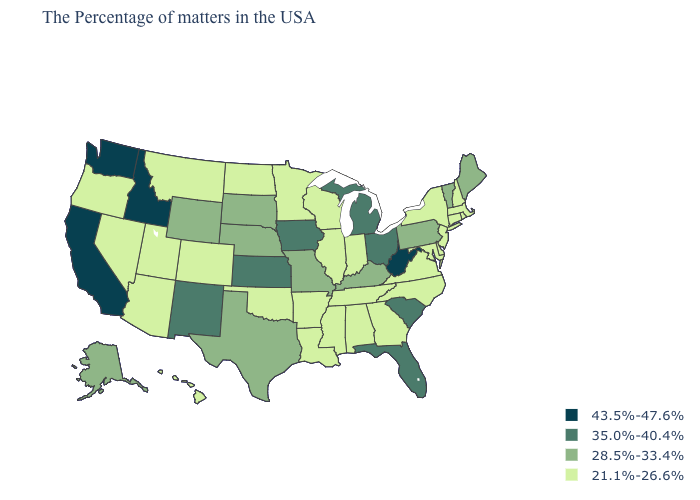What is the highest value in states that border Idaho?
Give a very brief answer. 43.5%-47.6%. Which states have the lowest value in the West?
Write a very short answer. Colorado, Utah, Montana, Arizona, Nevada, Oregon, Hawaii. Name the states that have a value in the range 21.1%-26.6%?
Be succinct. Massachusetts, Rhode Island, New Hampshire, Connecticut, New York, New Jersey, Delaware, Maryland, Virginia, North Carolina, Georgia, Indiana, Alabama, Tennessee, Wisconsin, Illinois, Mississippi, Louisiana, Arkansas, Minnesota, Oklahoma, North Dakota, Colorado, Utah, Montana, Arizona, Nevada, Oregon, Hawaii. Does South Dakota have the same value as Mississippi?
Be succinct. No. What is the value of New Hampshire?
Quick response, please. 21.1%-26.6%. Which states have the highest value in the USA?
Short answer required. West Virginia, Idaho, California, Washington. Name the states that have a value in the range 28.5%-33.4%?
Short answer required. Maine, Vermont, Pennsylvania, Kentucky, Missouri, Nebraska, Texas, South Dakota, Wyoming, Alaska. What is the value of Idaho?
Answer briefly. 43.5%-47.6%. Name the states that have a value in the range 43.5%-47.6%?
Write a very short answer. West Virginia, Idaho, California, Washington. What is the value of South Dakota?
Give a very brief answer. 28.5%-33.4%. What is the value of Kansas?
Concise answer only. 35.0%-40.4%. Among the states that border Michigan , does Indiana have the lowest value?
Quick response, please. Yes. Among the states that border Kansas , which have the lowest value?
Give a very brief answer. Oklahoma, Colorado. Does the first symbol in the legend represent the smallest category?
Be succinct. No. What is the value of New Mexico?
Write a very short answer. 35.0%-40.4%. 